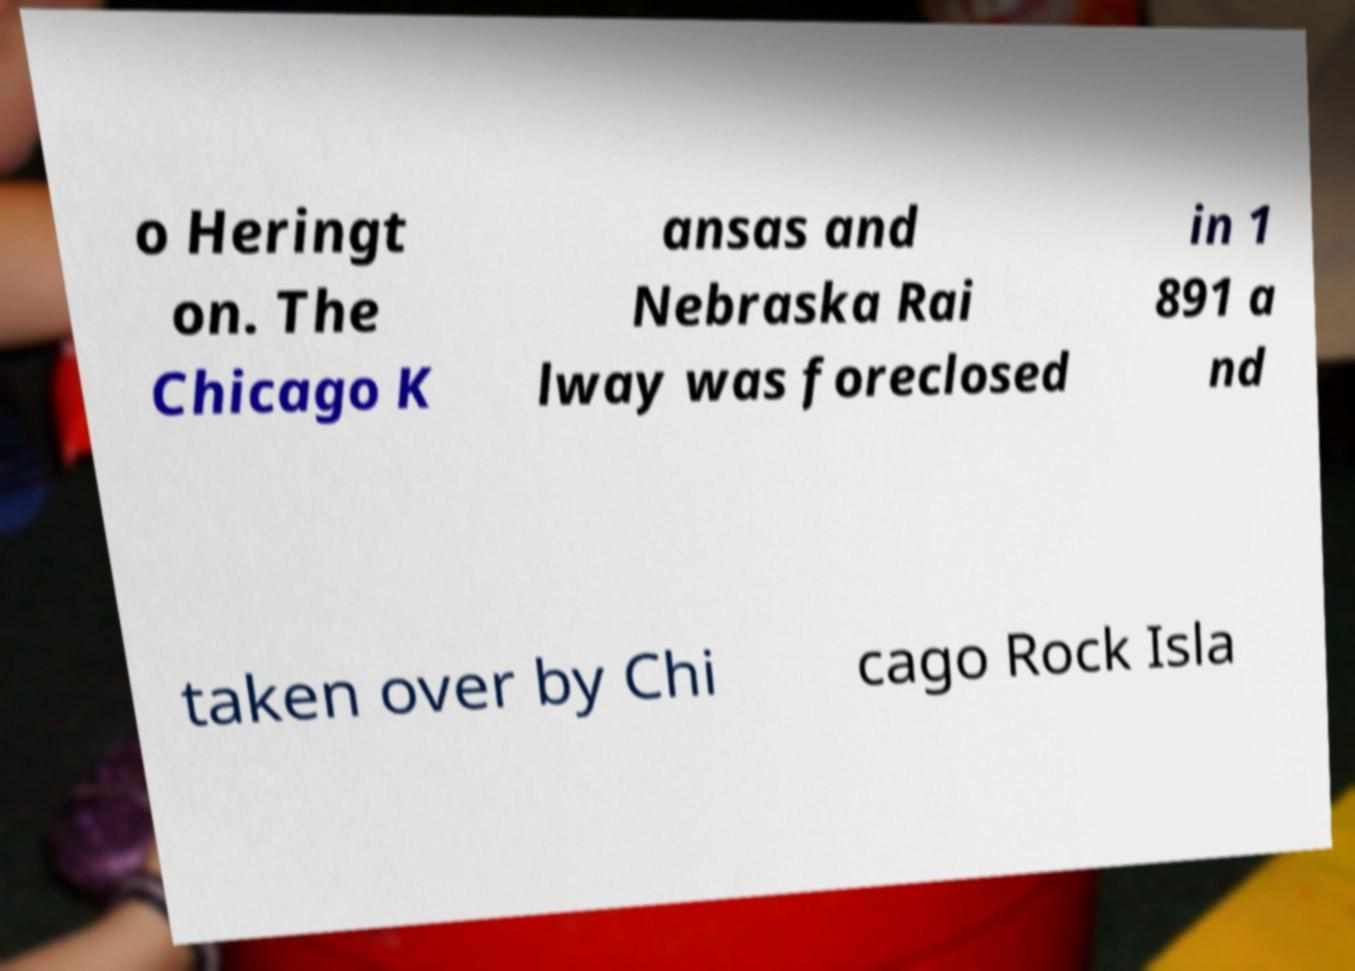There's text embedded in this image that I need extracted. Can you transcribe it verbatim? o Heringt on. The Chicago K ansas and Nebraska Rai lway was foreclosed in 1 891 a nd taken over by Chi cago Rock Isla 